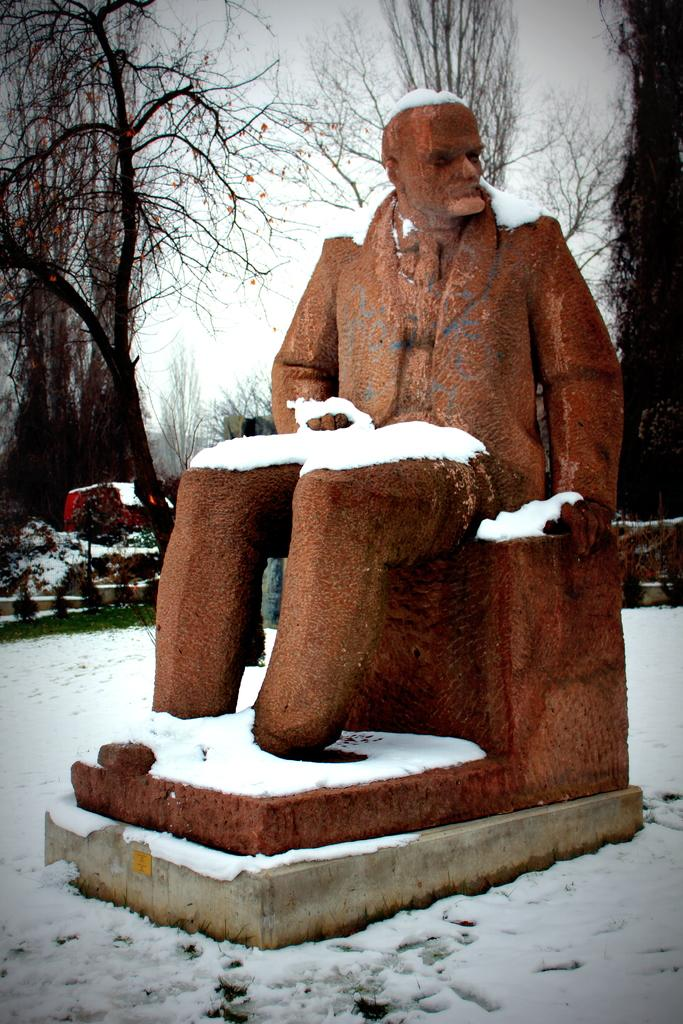What is the main subject of the image? There is a sculpture of a person at the center of the image. What is the person in the sculpture doing? The person is sitting. What is the environment like around the sculpture? There is snow around the sculpture. What can be seen in the background of the image? There are trees at the back of the image. What type of scent can be detected coming from the volcano in the image? There is no volcano present in the image, so it is not possible to detect any scent coming from a volcano. 